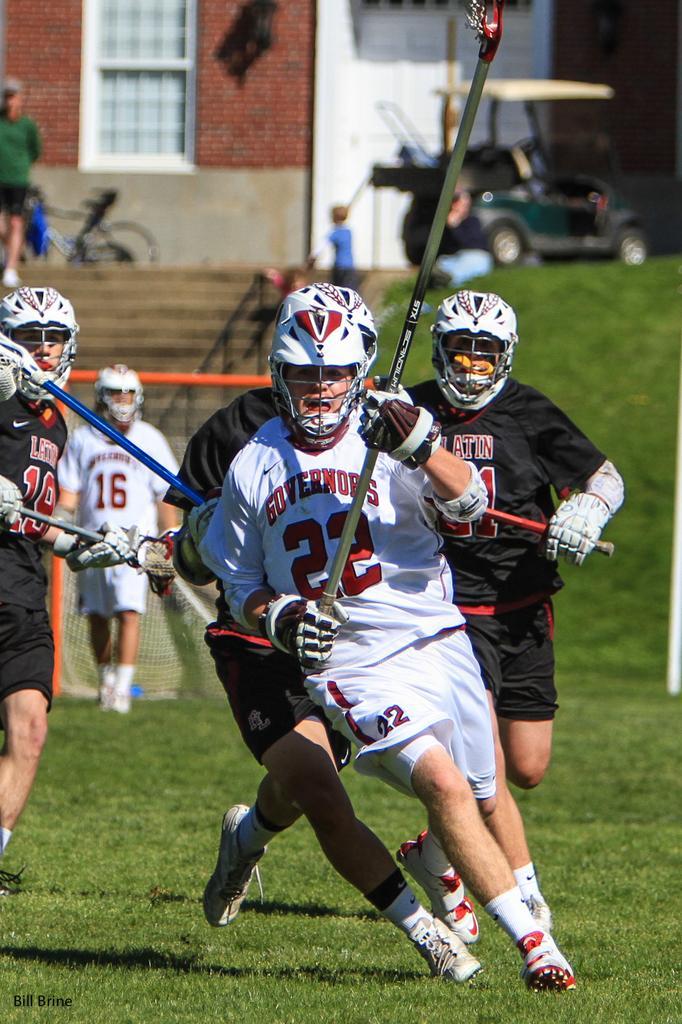Describe this image in one or two sentences. In this picture I can see there are few people playing and they are wearing a jersey and there is some grass on the floor and there is a boy and a person standing on the stairs in the backdrop and there is a building in the backdrop. 